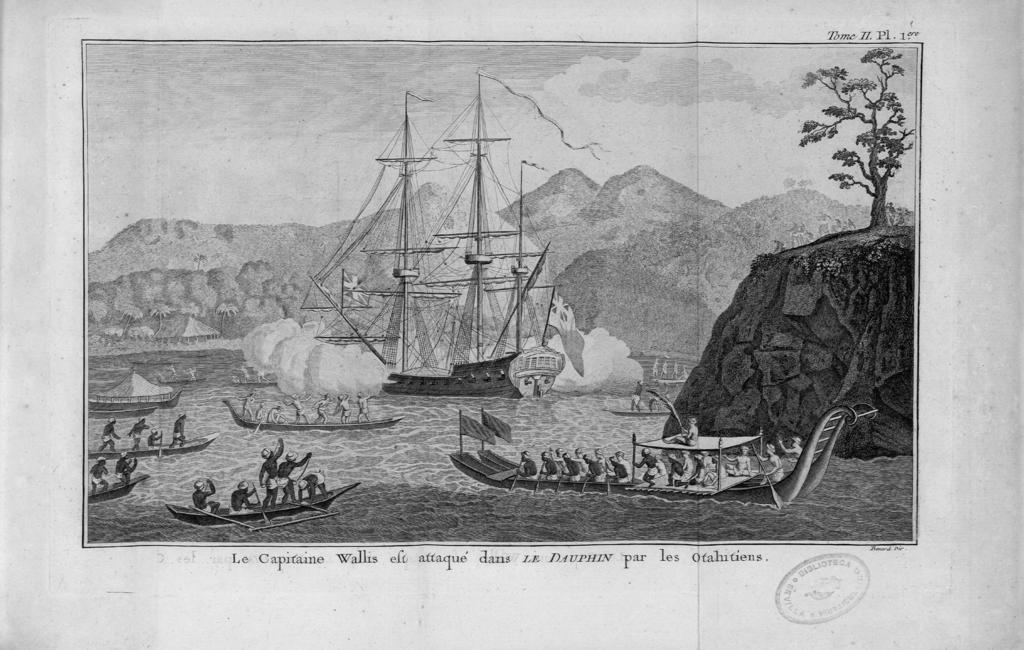How would you summarize this image in a sentence or two? This is a black and white image. In this image we can see the drawing of a ship in the water. We can also see boats with some people smiling holding the rows. On the backside we can see a group of trees, the mountains and the sky. On the bottom of the image we can see some printed text and a stamp on it. 